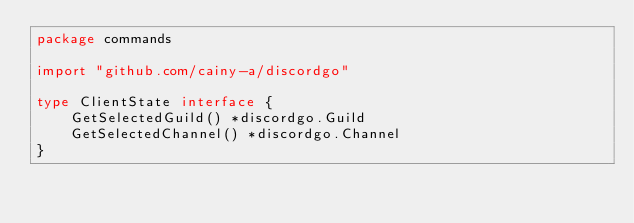<code> <loc_0><loc_0><loc_500><loc_500><_Go_>package commands

import "github.com/cainy-a/discordgo"

type ClientState interface {
	GetSelectedGuild() *discordgo.Guild
	GetSelectedChannel() *discordgo.Channel
}
</code> 